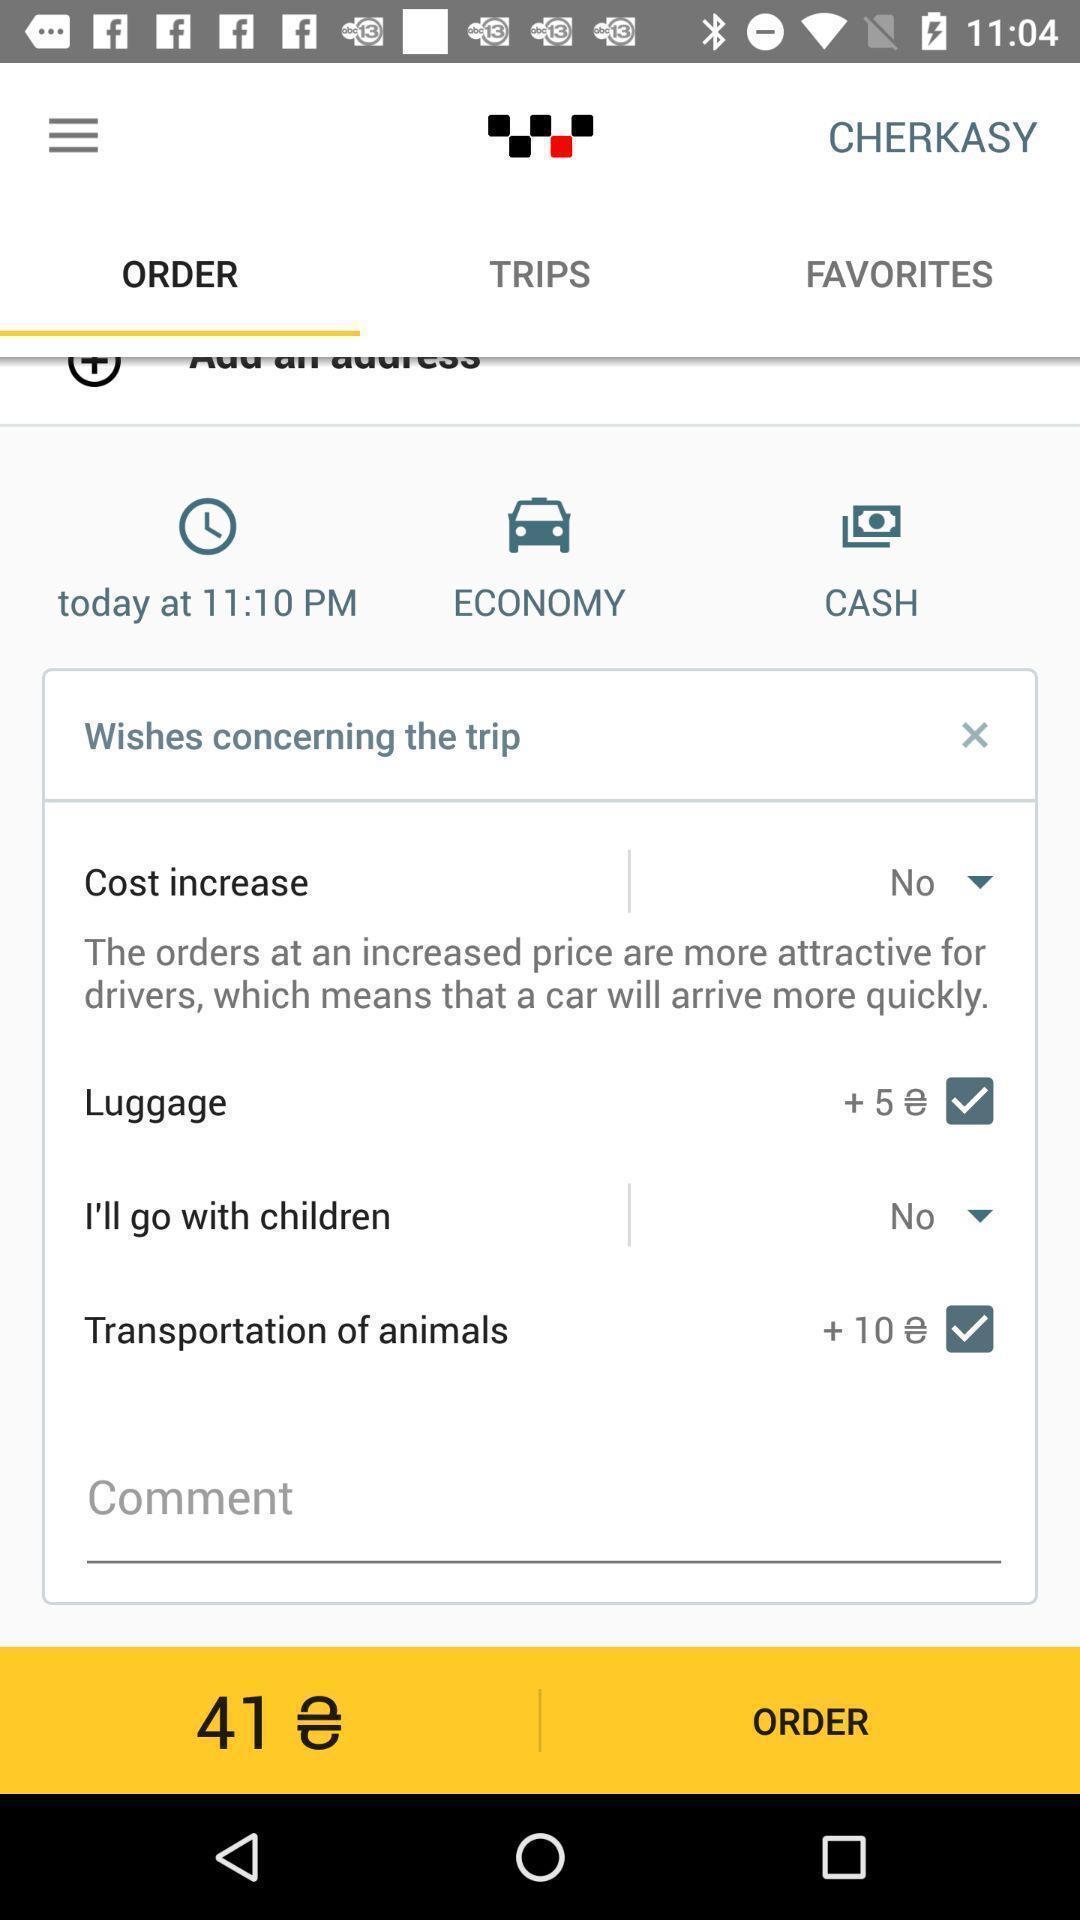Explain the elements present in this screenshot. Screen shows to order a taxi or other transport. 